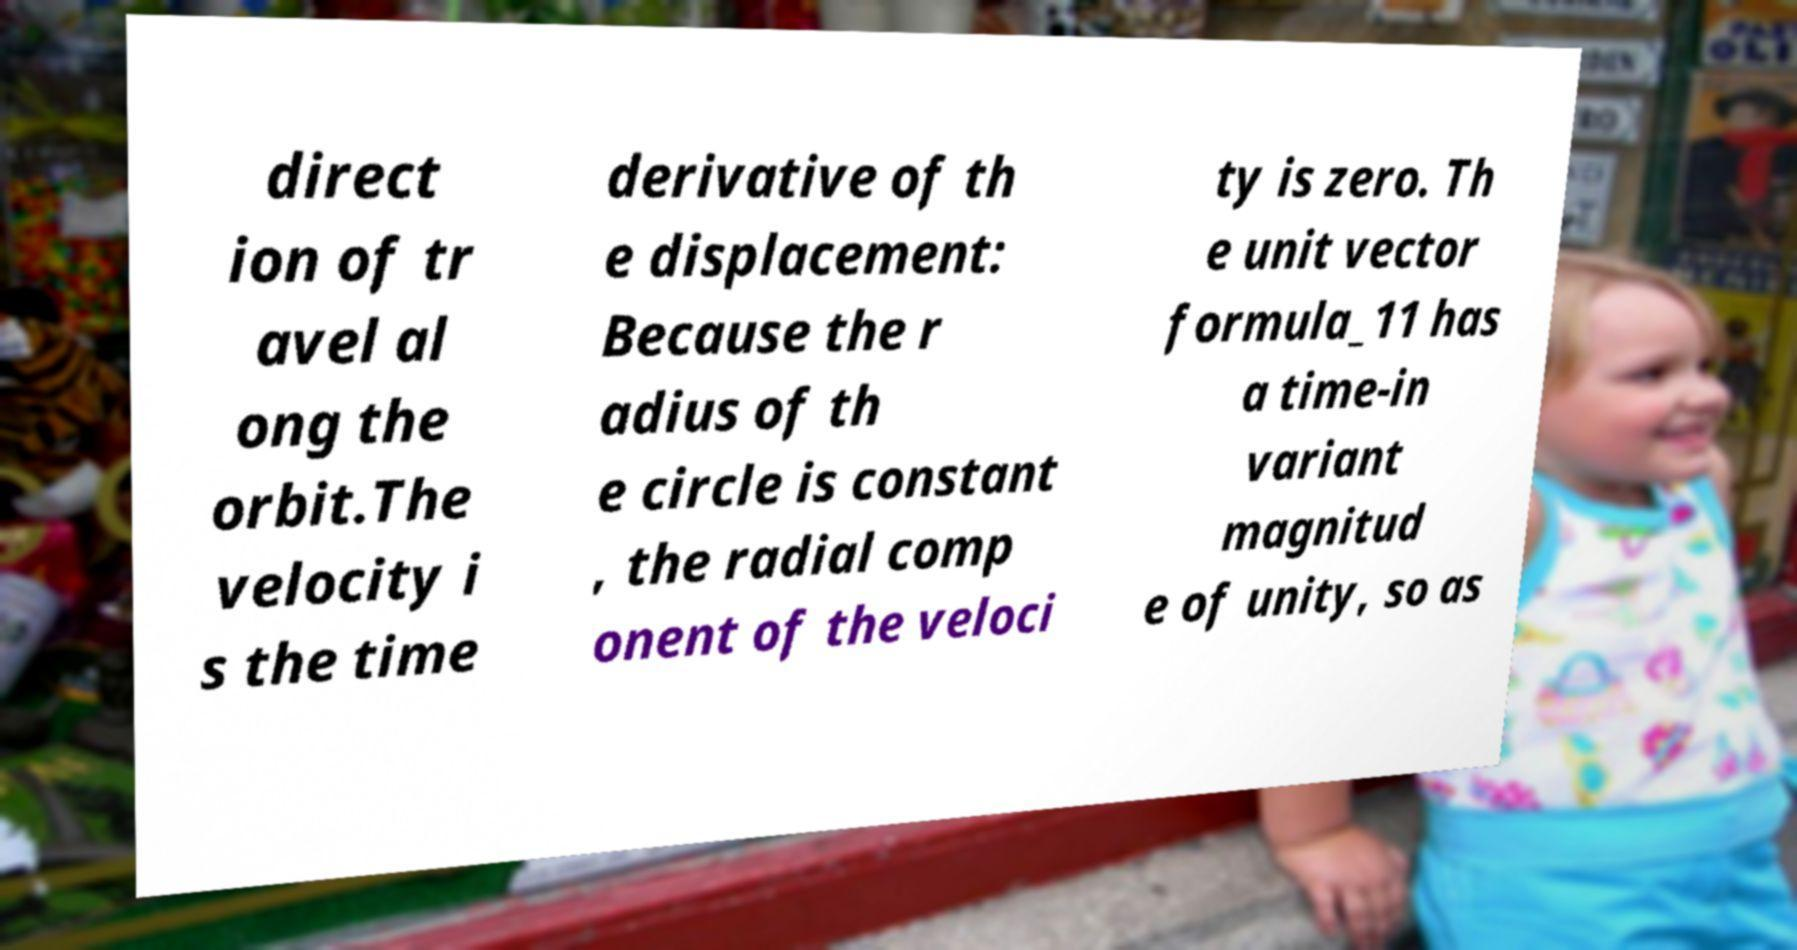Please identify and transcribe the text found in this image. direct ion of tr avel al ong the orbit.The velocity i s the time derivative of th e displacement: Because the r adius of th e circle is constant , the radial comp onent of the veloci ty is zero. Th e unit vector formula_11 has a time-in variant magnitud e of unity, so as 